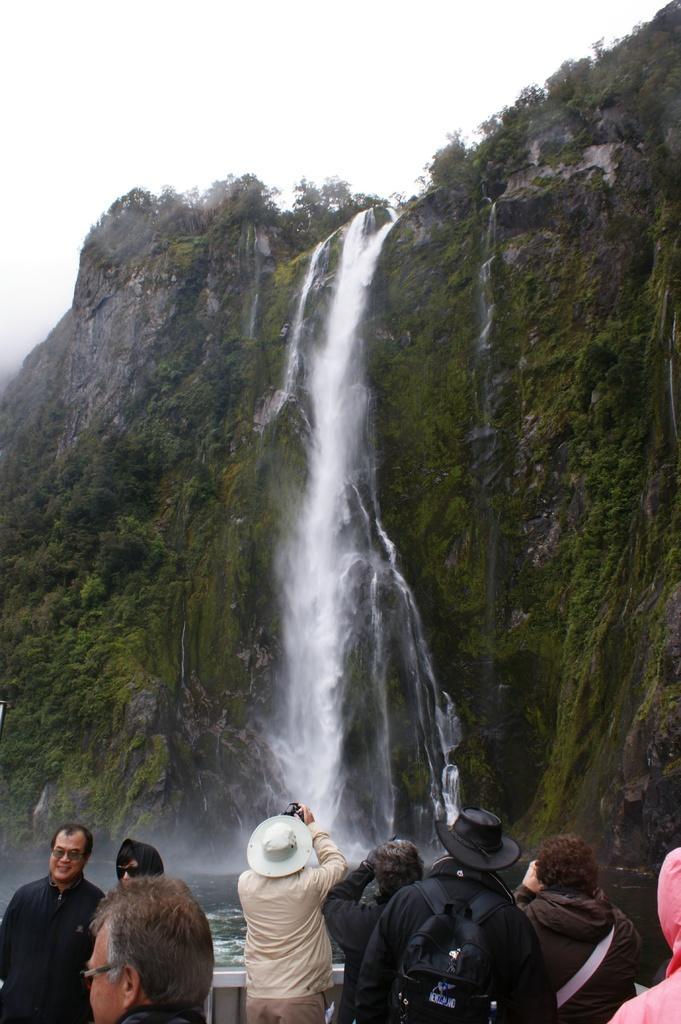In one or two sentences, can you explain what this image depicts? In this image there are some persons standing at bottom of this image. The person standing in middle of this image is wearing a cap and holding a camera. There is a waterfall in middle of this image and there is a sky at top of this image. 